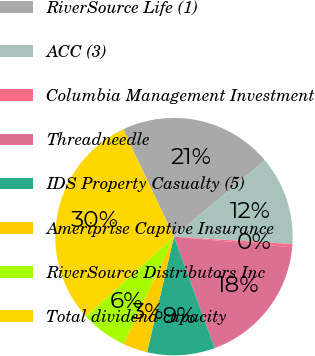Convert chart to OTSL. <chart><loc_0><loc_0><loc_500><loc_500><pie_chart><fcel>RiverSource Life (1)<fcel>ACC (3)<fcel>Columbia Management Investment<fcel>Threadneedle<fcel>IDS Property Casualty (5)<fcel>Ameriprise Captive Insurance<fcel>RiverSource Distributors Inc<fcel>Total dividend capacity<nl><fcel>20.91%<fcel>12.13%<fcel>0.43%<fcel>17.98%<fcel>9.21%<fcel>3.36%<fcel>6.28%<fcel>29.69%<nl></chart> 